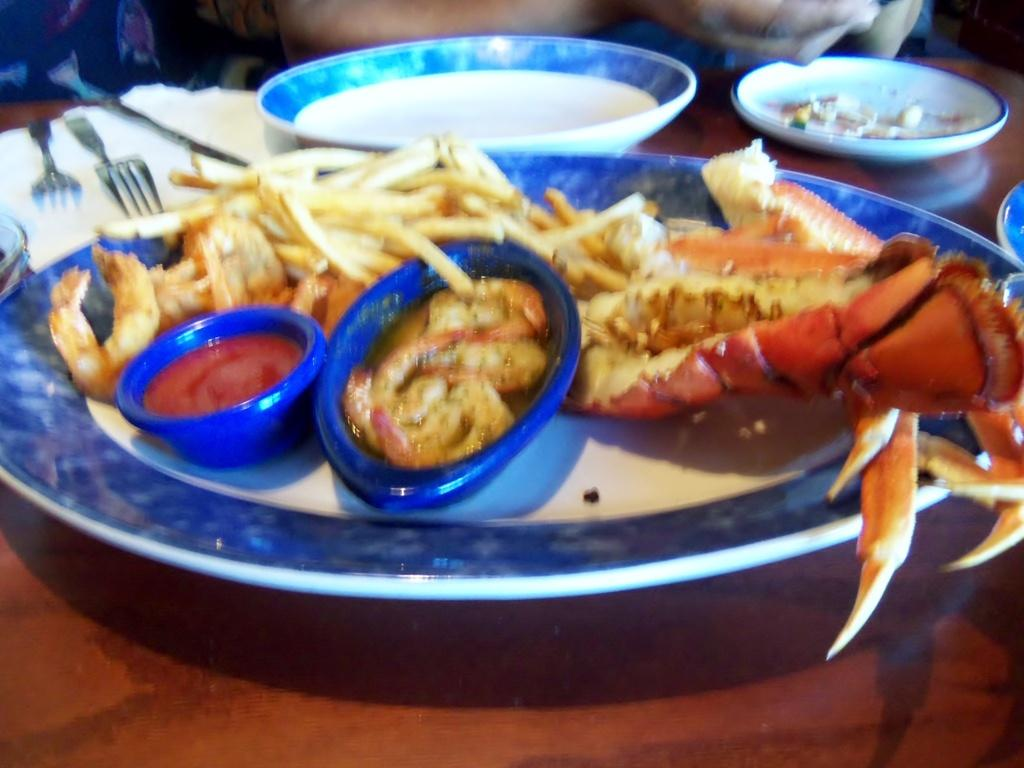What type of sea creature is present in the image? There is a crab in the image. What type of food is visible in the image? There are french fries, tomato sauce, and soup in the image. What piece of furniture is present in the image? There is a table in the image. What items are on the table in the image? There is a plate with a fork, knife, and tissue on the table. Where is the bee in the image? There is no bee present in the image. What type of bread is on the table in the image? There is no loaf of bread present in the image. 